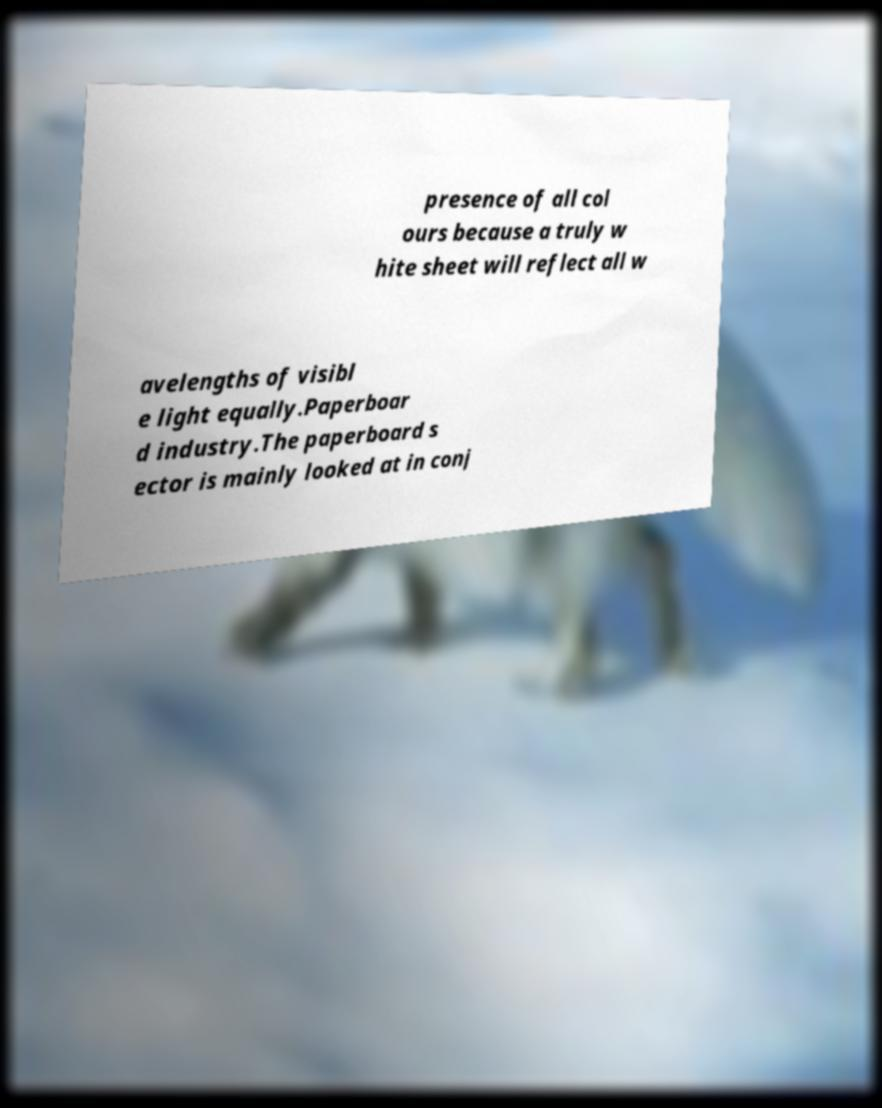Can you read and provide the text displayed in the image?This photo seems to have some interesting text. Can you extract and type it out for me? presence of all col ours because a truly w hite sheet will reflect all w avelengths of visibl e light equally.Paperboar d industry.The paperboard s ector is mainly looked at in conj 